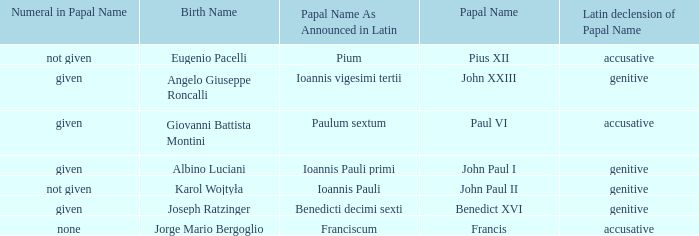For Pope Paul VI, what is the declension of his papal name? Accusative. 